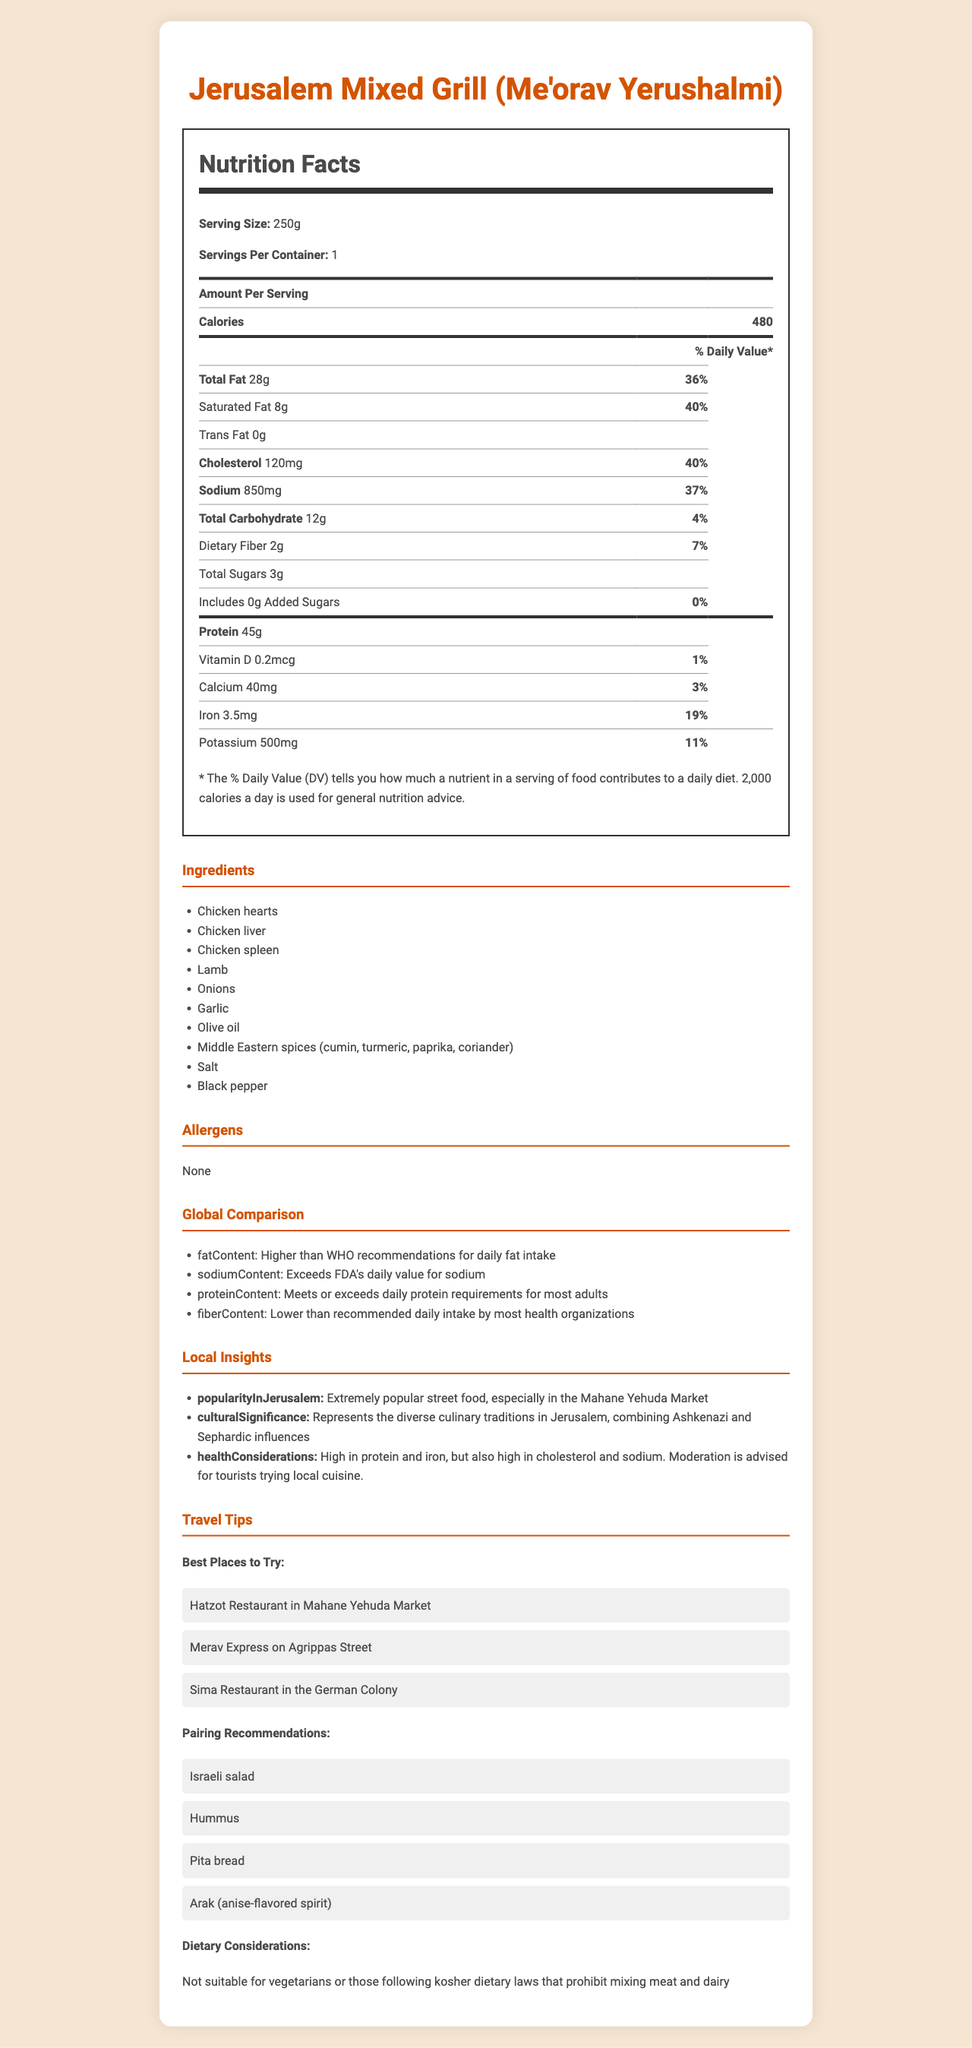What is the serving size of Jerusalem Mixed Grill? The serving size is listed at the beginning of the Nutrition Facts section.
Answer: 250g How many calories are there per serving? The number of calories per serving is stated as 480 in the Nutrition Facts section.
Answer: 480 How much total fat does one serving contain? The total fat content per serving is mentioned as 28g in the Nutrition Facts.
Answer: 28g What is the daily value percentage for sodium in Jerusalem Mixed Grill? The daily value percentage for sodium is listed as 37% in the Nutrition Facts.
Answer: 37% What is the amount of protein per serving? The amount of protein per serving is mentioned as 45g in the Nutrition Facts section.
Answer: 45g Which of the following best describes the fiber content in the dish compared to global recommendations?
1. Higher than recommended
2. Lower than recommended
3. Meets recommendations The global comparison section states that the fiber content is lower than the recommended daily intake by most health organizations.
Answer: 2. Lower than recommended Which restaurant is suggested as the best place to try Jerusalem Mixed Grill in Mahane Yehuda Market?
A. Sima Restaurant
B. Merav Express
C. Hatzot Restaurant The travel tips recommend Hatzot Restaurant in the Mahane Yehuda Market as one of the best places to try Jerusalem Mixed Grill.
Answer: C. Hatzot Restaurant Is the Jerusalem Mixed Grill suitable for vegetarians? The travel tips section mentions that the dish is not suitable for vegetarians due to its ingredients, which include chicken and lamb.
Answer: No Briefly describe the main nutritional concerns for someone eating Jerusalem Mixed Grill. The local insights section highlights that the dish is high in protein and iron but also has high levels of cholesterol and sodium, advising moderation for tourists.
Answer: High in protein and iron, but also high in cholesterol and sodium. Moderation is advised. What are the Middle Eastern spices used in Jerusalem Mixed Grill? The ingredients list specifies the Middle Eastern spices used in the dish.
Answer: Cumin, turmeric, paprika, and coriander What is the vitamin D content in the dish, and what percentage of the daily value does it represent? The Nutrition Facts state that the dish contains 0.2mcg of vitamin D, which represents 1% of the daily value.
Answer: 0.2mcg, 1% Can the information about the allergens be determined from the document? The document explicitly states that there are no allergens in the dish.
Answer: Yes, there are no allergens listed. What are some recommended food pairings with Jerusalem Mixed Grill according to the document? The travel tips section recommends pairing Jerusalem Mixed Grill with Israeli salad, hummus, pita bread, and arak (anise-flavored spirit).
Answer: Israeli salad, hummus, pita bread, and arak Is the total sugar content in the dish higher than the added sugars? The total sugars amount to 3g, whereas the added sugars are 0g, indicating the total sugar content is higher than the added sugars.
Answer: Yes How does the sodium content in Jerusalem Mixed Grill compare to FDA daily values? The global comparison section indicates that the sodium content in the dish exceeds the FDA's daily value for sodium.
Answer: Exceeds FDA's daily value Which one of the following health organizations' recommendations does the fat content of Jerusalem Mixed Grill surpass?
i. WHO
ii. FDA
iii. USDA The global comparison section mentions that the fat content of the dish is higher than WHO recommendations for daily fat intake.
Answer: i. WHO Does the document provide enough information to determine whether Jerusalem Mixed Grill is kosher? The document does not provide any details about kosher certification or adherence to kosher dietary laws, so it cannot be determined.
Answer: No 